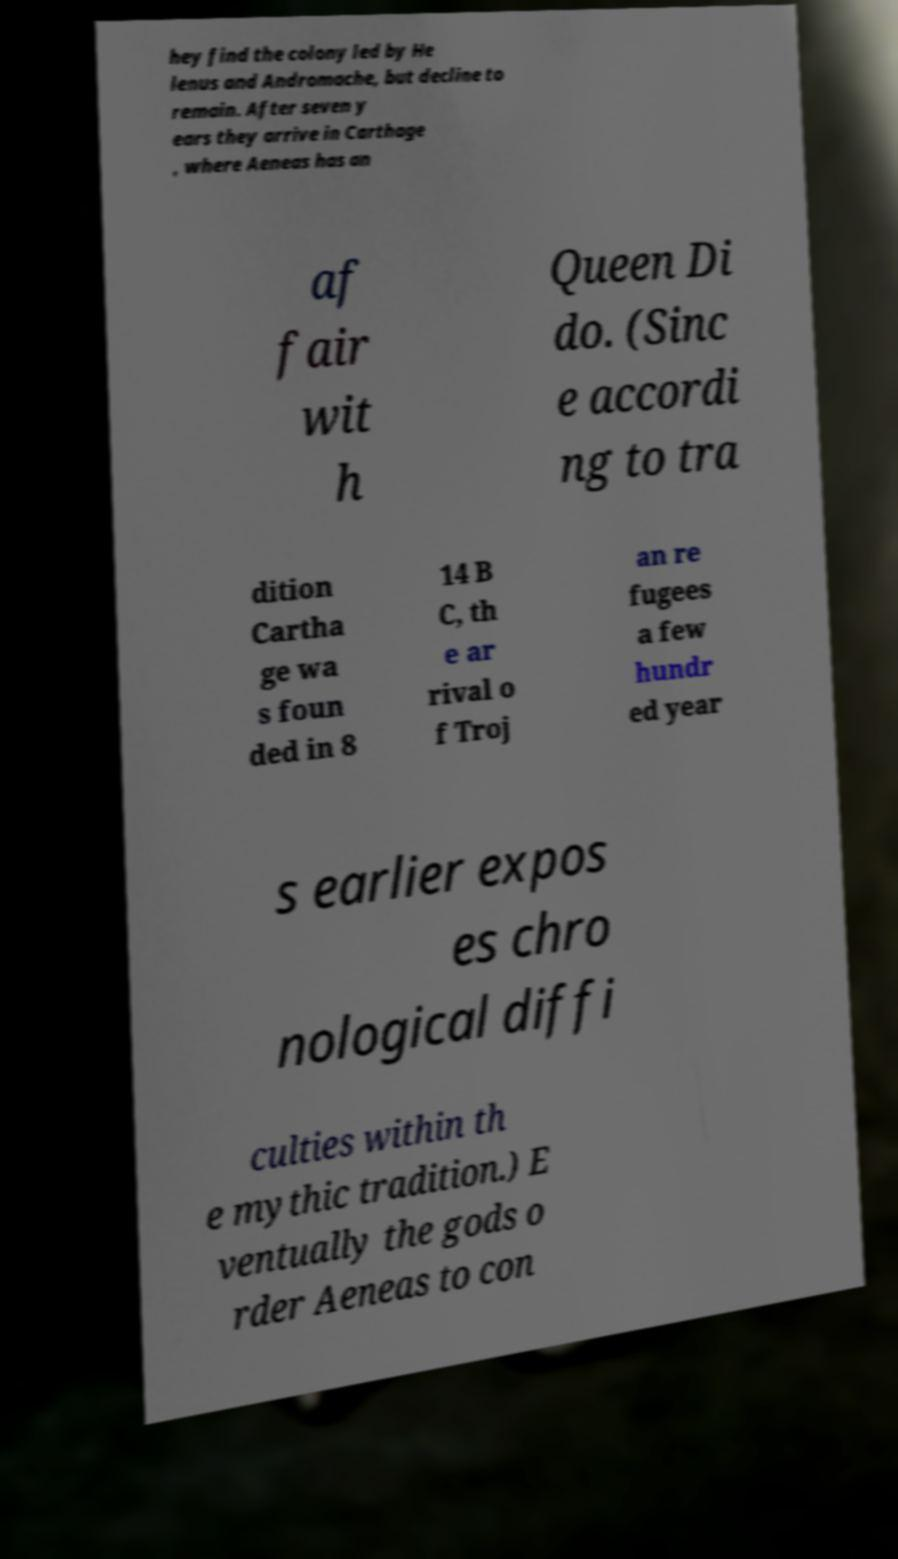For documentation purposes, I need the text within this image transcribed. Could you provide that? hey find the colony led by He lenus and Andromache, but decline to remain. After seven y ears they arrive in Carthage , where Aeneas has an af fair wit h Queen Di do. (Sinc e accordi ng to tra dition Cartha ge wa s foun ded in 8 14 B C, th e ar rival o f Troj an re fugees a few hundr ed year s earlier expos es chro nological diffi culties within th e mythic tradition.) E ventually the gods o rder Aeneas to con 